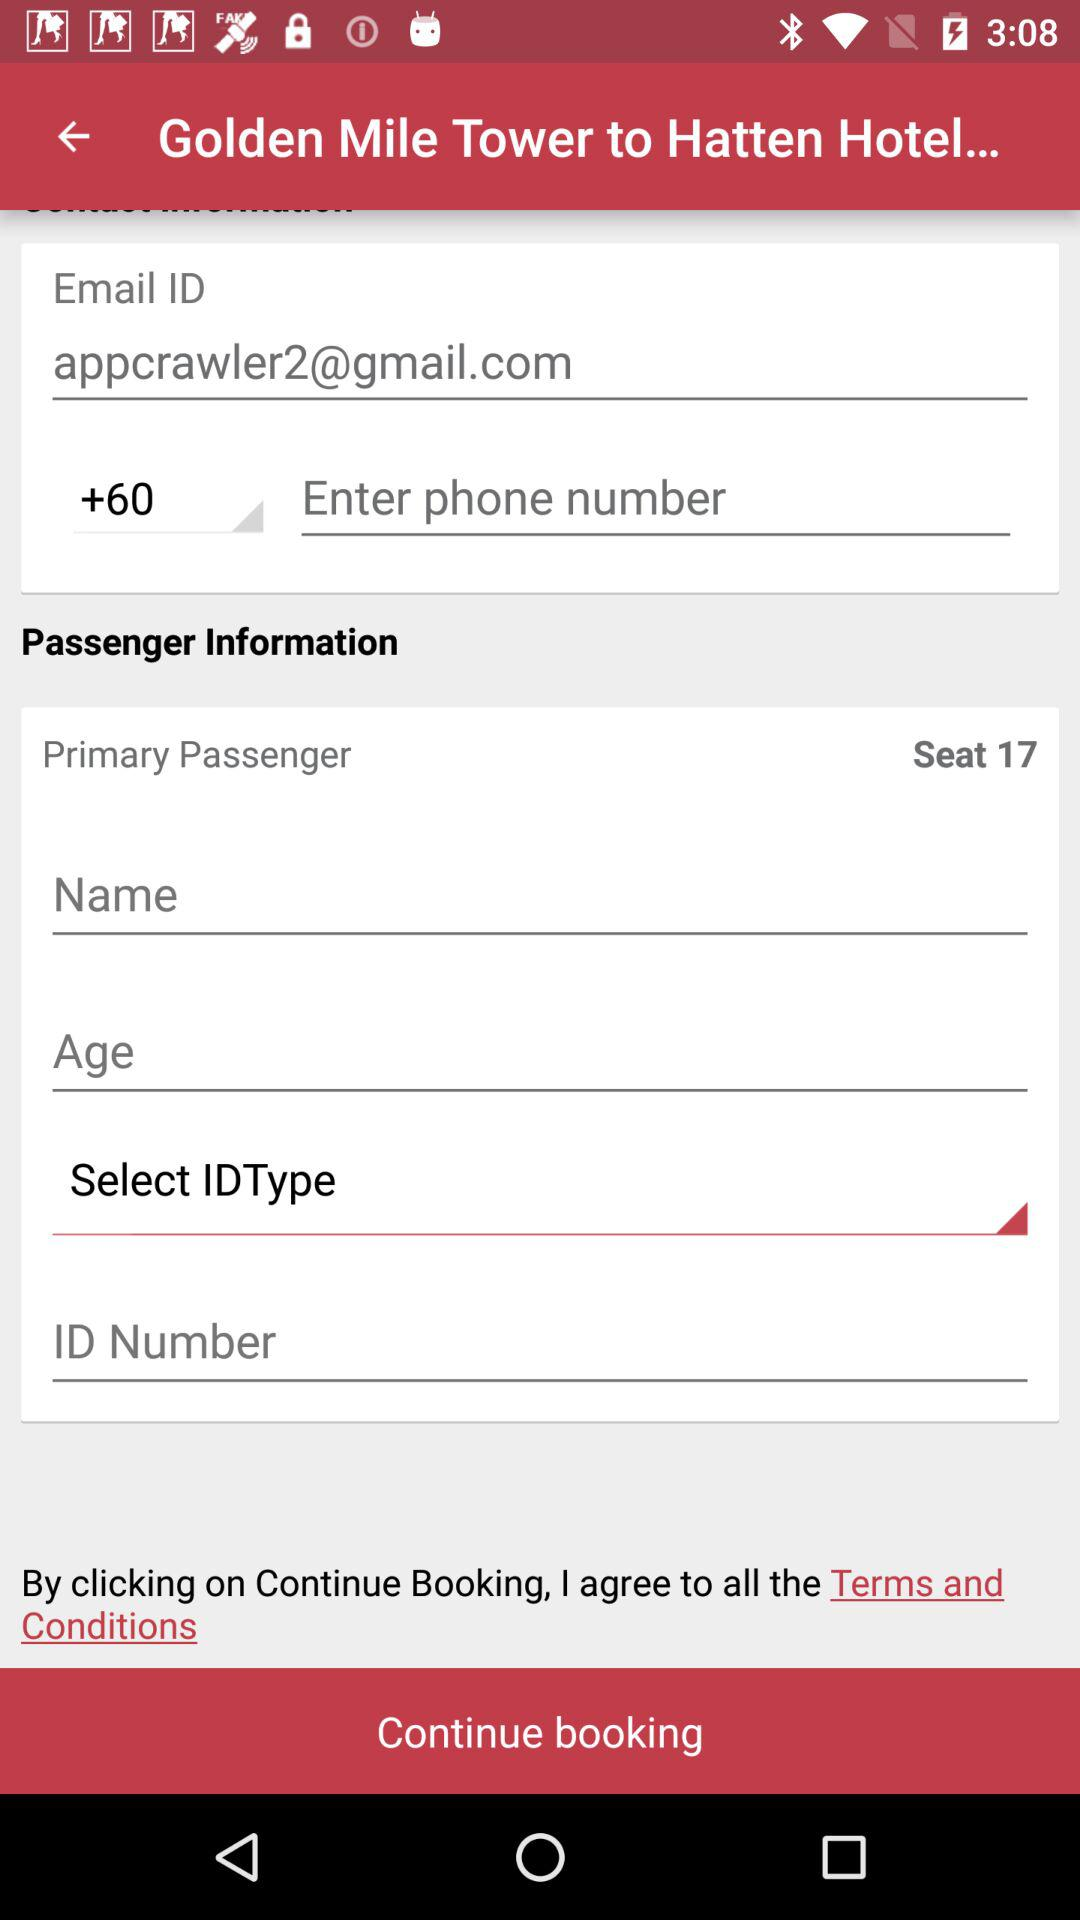What is the country code? The country code is +60. 